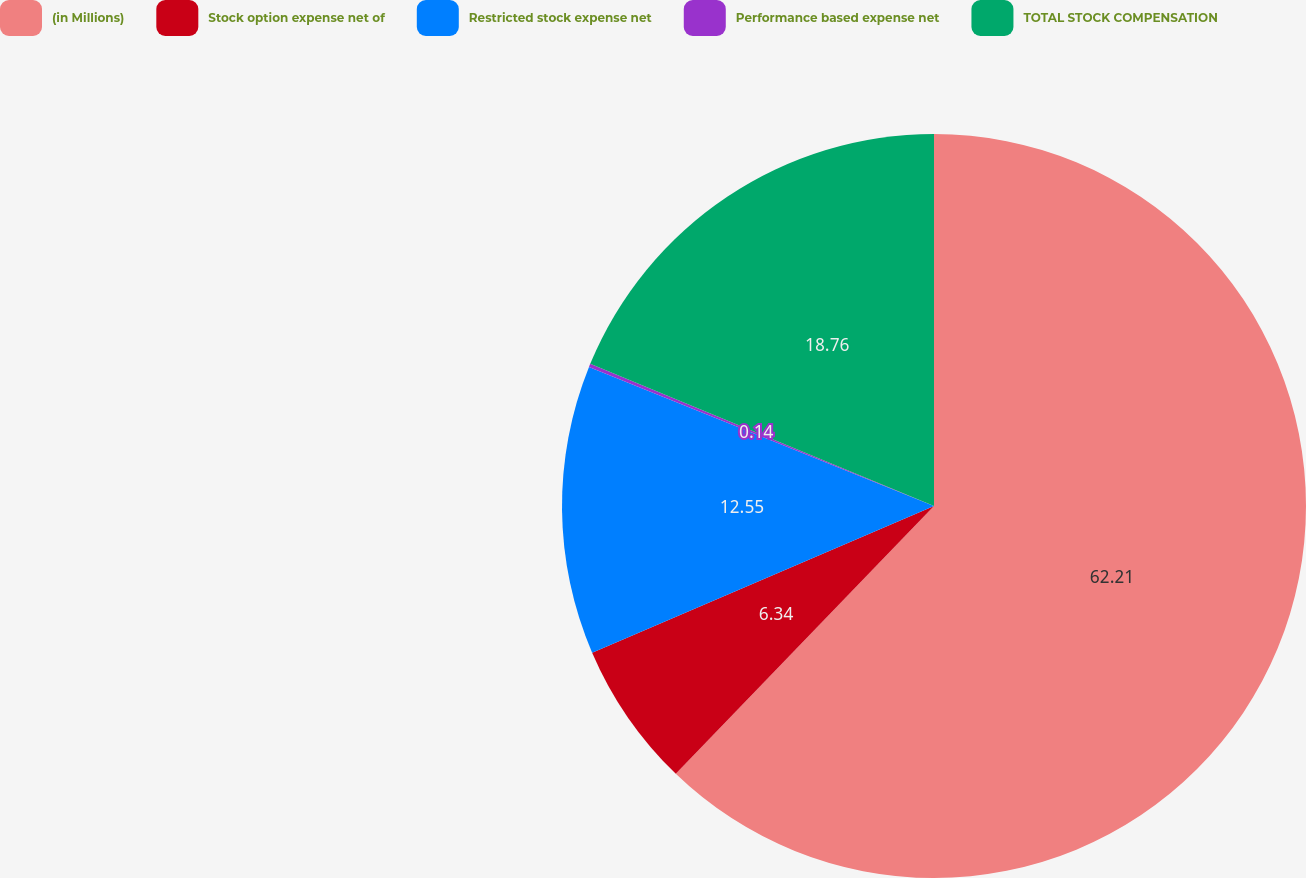Convert chart. <chart><loc_0><loc_0><loc_500><loc_500><pie_chart><fcel>(in Millions)<fcel>Stock option expense net of<fcel>Restricted stock expense net<fcel>Performance based expense net<fcel>TOTAL STOCK COMPENSATION<nl><fcel>62.21%<fcel>6.34%<fcel>12.55%<fcel>0.14%<fcel>18.76%<nl></chart> 